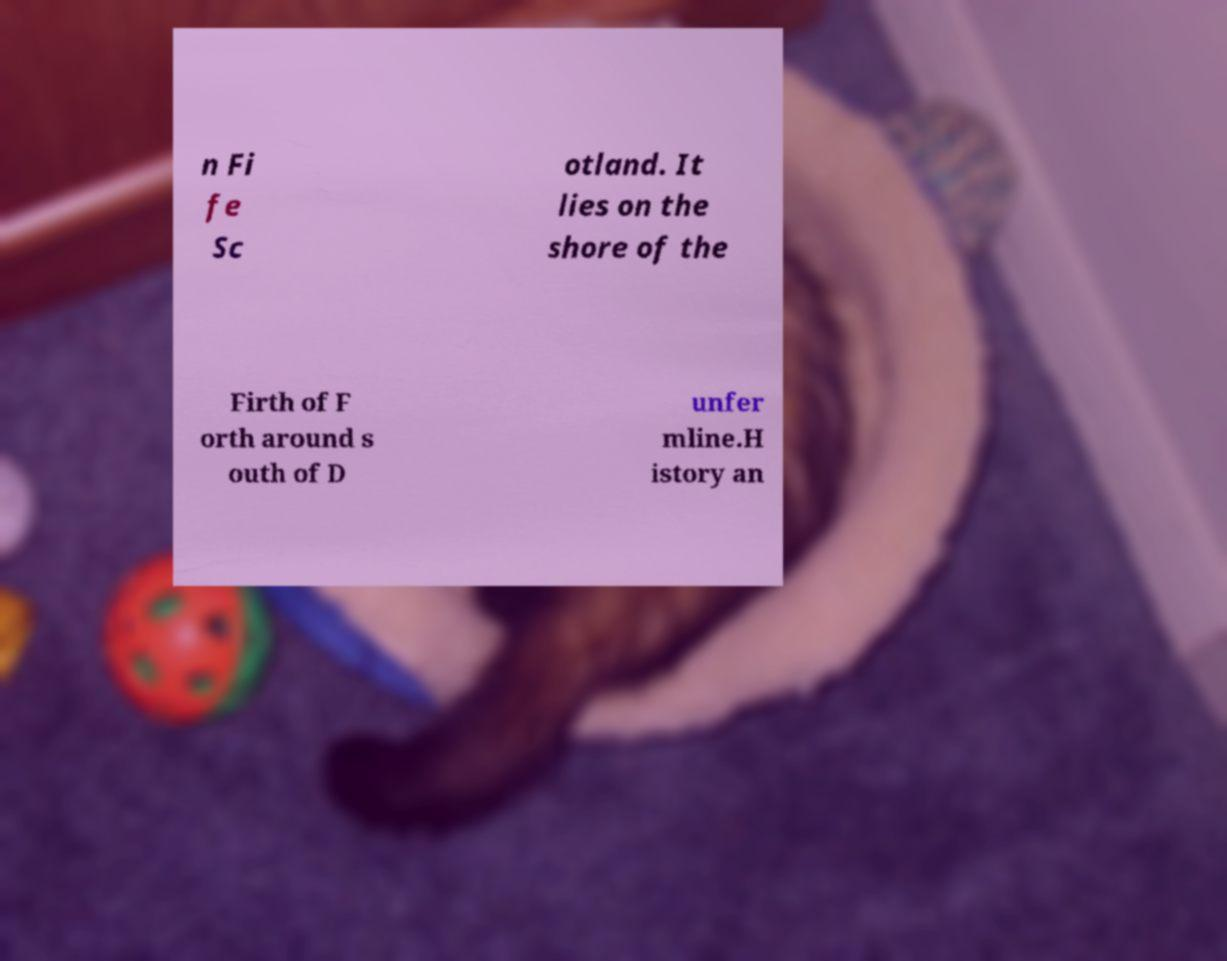Please identify and transcribe the text found in this image. n Fi fe Sc otland. It lies on the shore of the Firth of F orth around s outh of D unfer mline.H istory an 